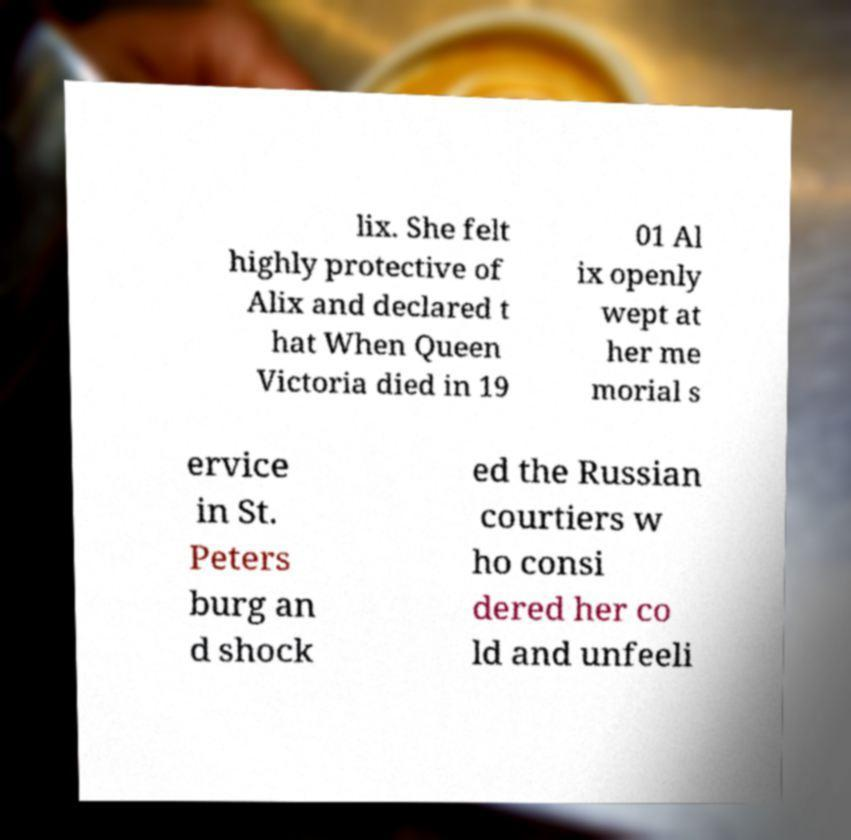Please identify and transcribe the text found in this image. lix. She felt highly protective of Alix and declared t hat When Queen Victoria died in 19 01 Al ix openly wept at her me morial s ervice in St. Peters burg an d shock ed the Russian courtiers w ho consi dered her co ld and unfeeli 